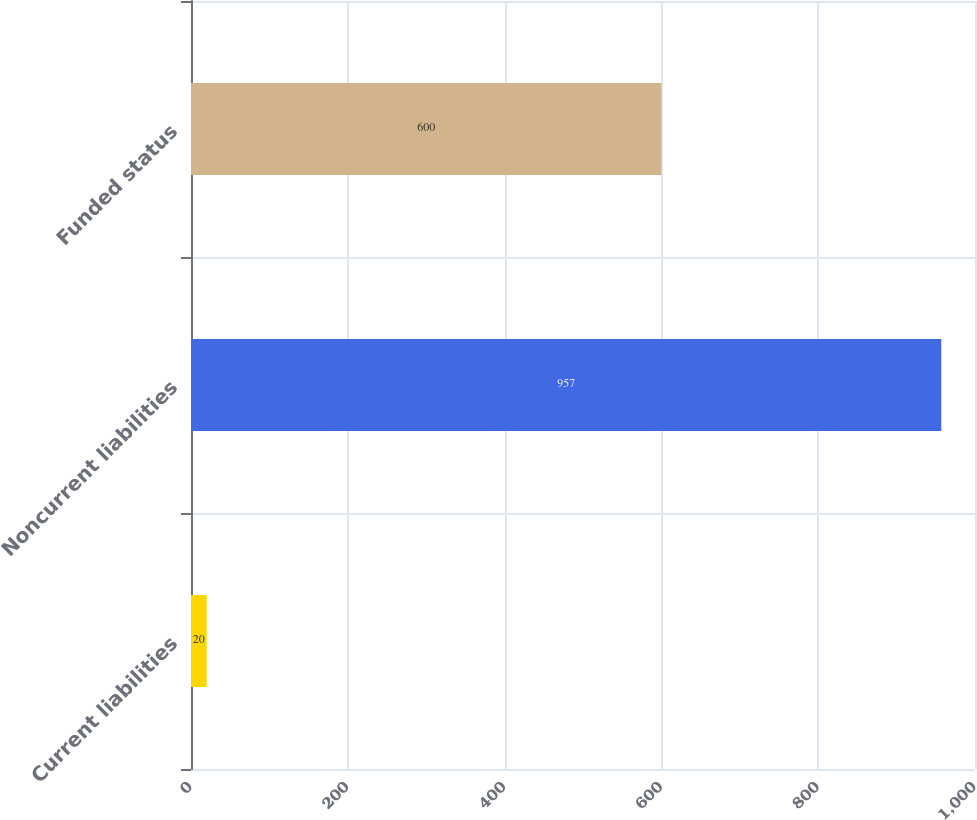Convert chart. <chart><loc_0><loc_0><loc_500><loc_500><bar_chart><fcel>Current liabilities<fcel>Noncurrent liabilities<fcel>Funded status<nl><fcel>20<fcel>957<fcel>600<nl></chart> 